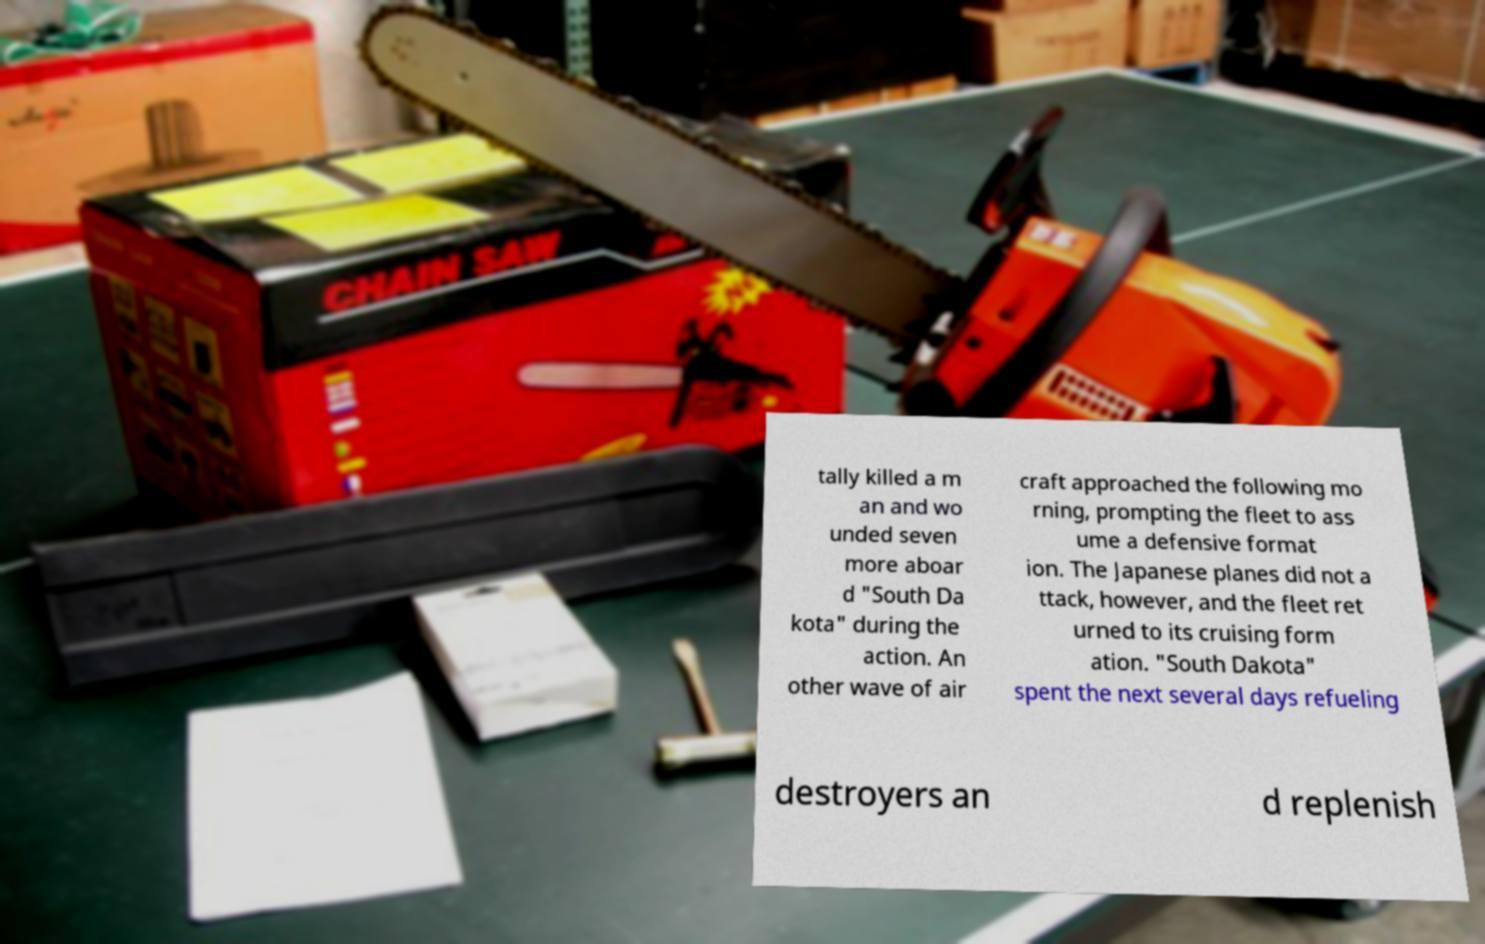Could you assist in decoding the text presented in this image and type it out clearly? tally killed a m an and wo unded seven more aboar d "South Da kota" during the action. An other wave of air craft approached the following mo rning, prompting the fleet to ass ume a defensive format ion. The Japanese planes did not a ttack, however, and the fleet ret urned to its cruising form ation. "South Dakota" spent the next several days refueling destroyers an d replenish 